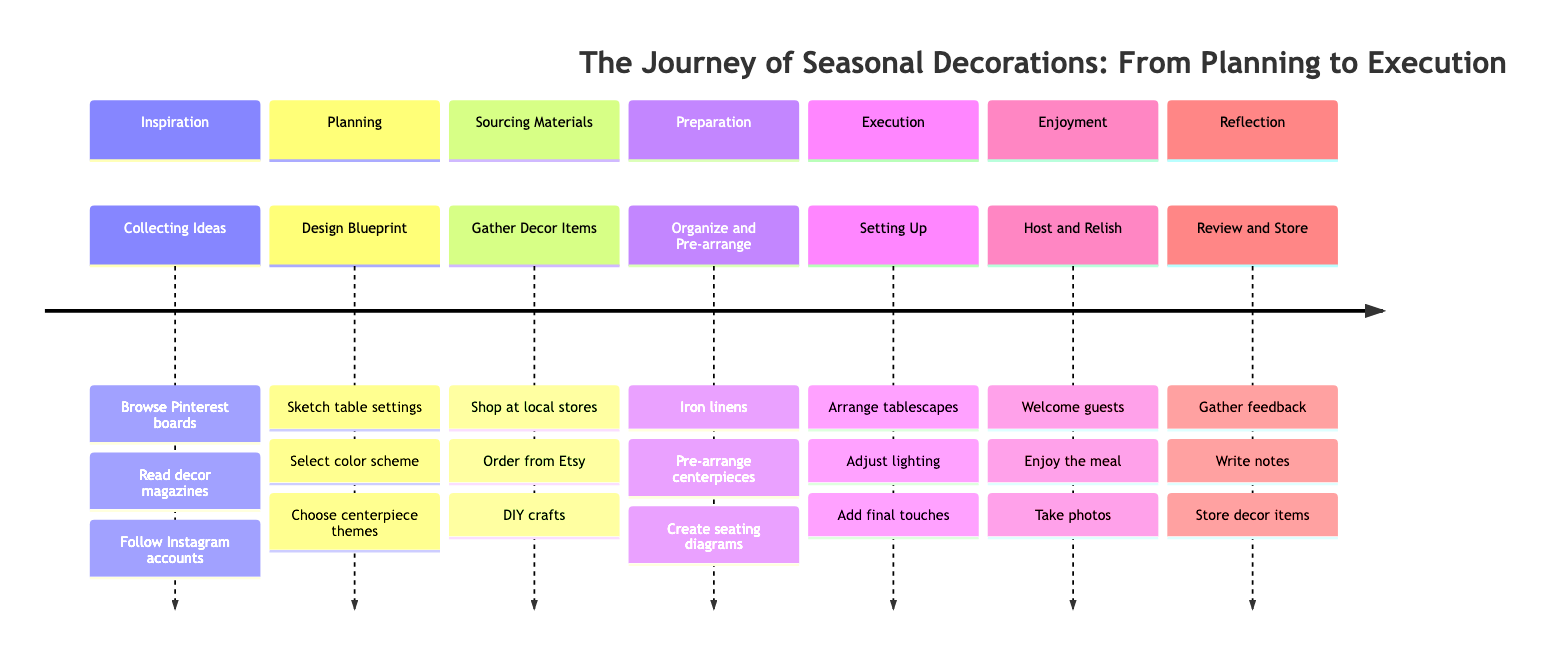What is the first phase of the decoration journey? The first phase listed in the diagram is "Inspiration." This is the starting point for gathering ideas and forms the basis for the succeeding phases.
Answer: Inspiration How many activities are in the "Sourcing Materials" phase? In the diagram, the "Sourcing Materials" phase contains three activities: shopping at local stores, ordering from Etsy, and DIY crafts. Therefore, the total is three activities.
Answer: 3 What is the last activity in the "Reflection" phase? The last activity listed under the "Reflection" phase in the diagram is "Store decor items." This is the final step after gathering feedback and writing notes.
Answer: Store decor items Which phase involves "Adjust lighting"? The activity "Adjust lighting" is located in the "Execution" phase. This phase specifically focuses on the setup and completing the table arrangement.
Answer: Execution What is the relationship between "Preparation" and "Execution" phases? The relationship is sequential; "Preparation" comes before "Execution." Preparations must be finalized before the actual setup takes place in the Execution phase.
Answer: Sequential How many phases are involved in the entire decoration journey? The diagram outlines a total of seven distinct phases in the journey of seasonal decorations, starting from Inspiration and concluding with Reflection.
Answer: 7 What item should be pre-arranged during "Preparation"? During the "Preparation" phase, the activity of "Pre-arrange centerpieces" is specified as an essential task to ensure everything is ready for the setup.
Answer: Pre-arrange centerpieces What comes immediately after "Planning" in the timeline? The phase that follows "Planning" in the timeline is "Sourcing Materials." This is the next step after creating the design blueprint.
Answer: Sourcing Materials Which activity involves guests in the "Enjoyment" phase? In the "Enjoyment" phase, the activity that directly involves guests is "Welcome guests to the beautifully set table," indicating the start of the dinner party atmosphere.
Answer: Welcome guests to the beautifully set table 